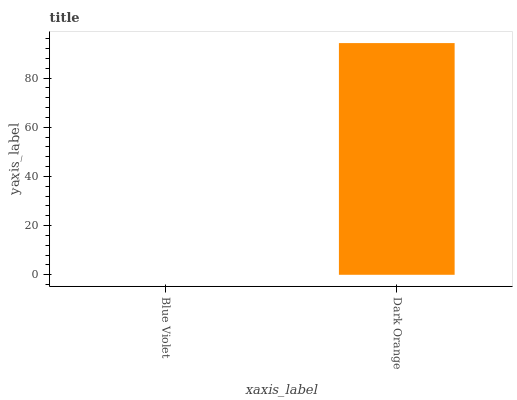Is Blue Violet the minimum?
Answer yes or no. Yes. Is Dark Orange the maximum?
Answer yes or no. Yes. Is Dark Orange the minimum?
Answer yes or no. No. Is Dark Orange greater than Blue Violet?
Answer yes or no. Yes. Is Blue Violet less than Dark Orange?
Answer yes or no. Yes. Is Blue Violet greater than Dark Orange?
Answer yes or no. No. Is Dark Orange less than Blue Violet?
Answer yes or no. No. Is Dark Orange the high median?
Answer yes or no. Yes. Is Blue Violet the low median?
Answer yes or no. Yes. Is Blue Violet the high median?
Answer yes or no. No. Is Dark Orange the low median?
Answer yes or no. No. 